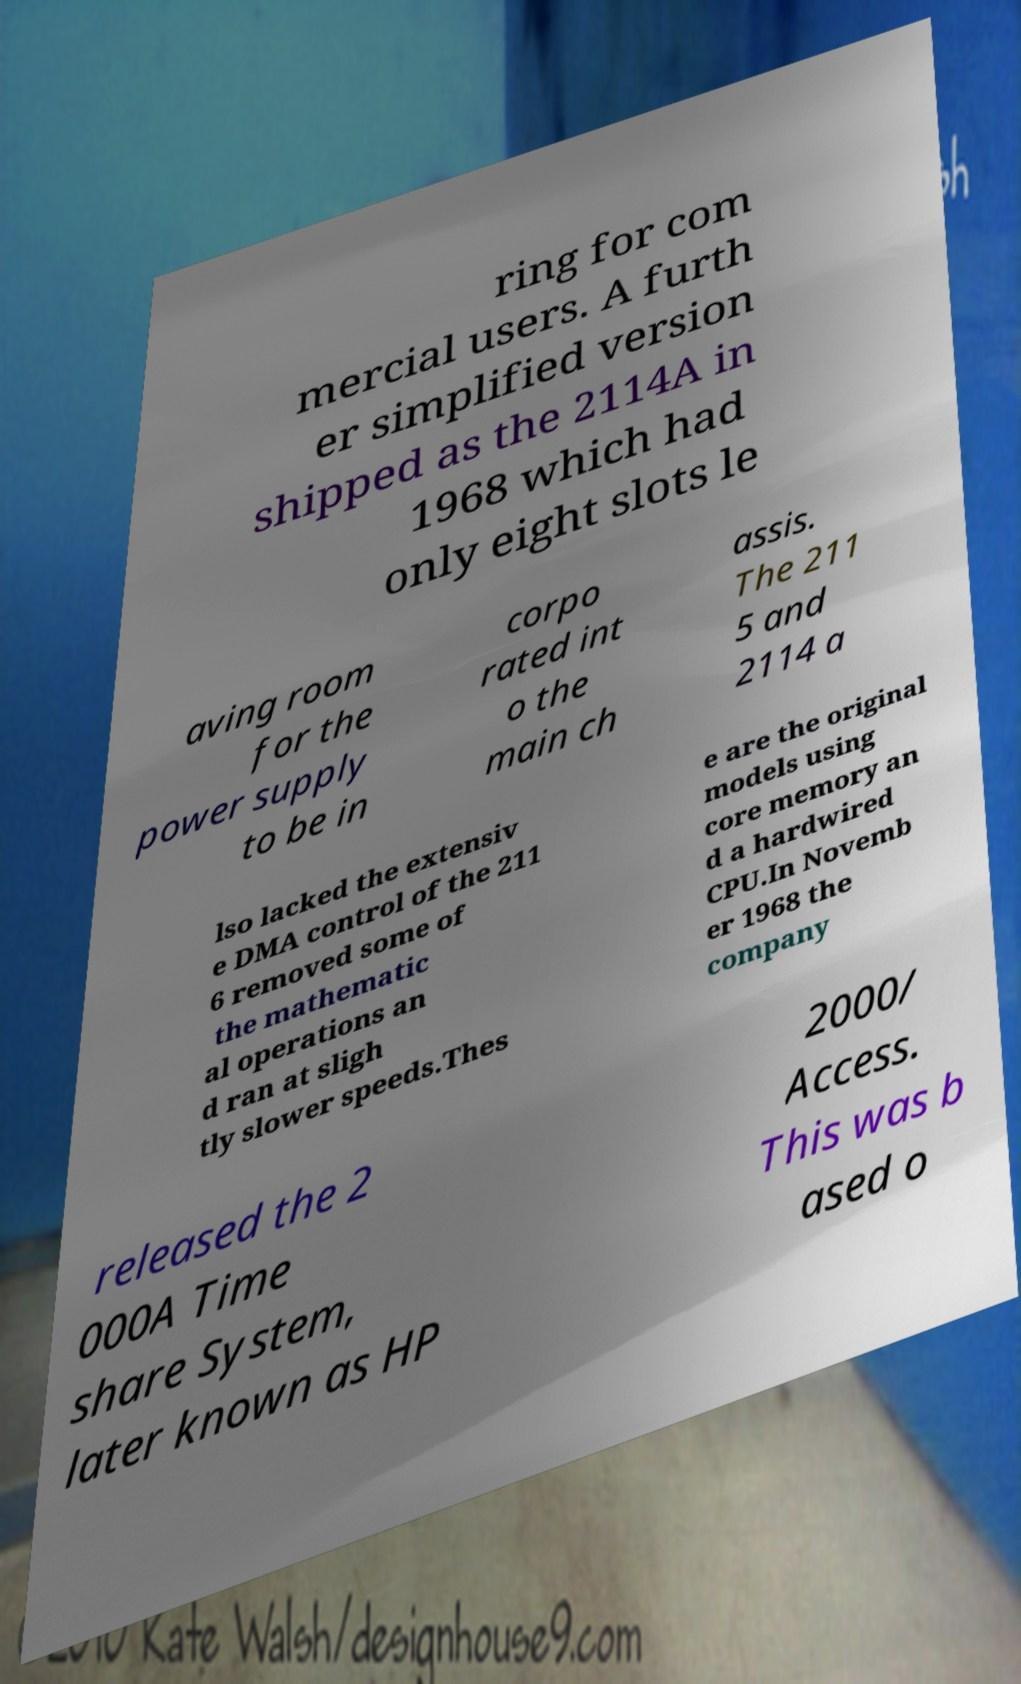There's text embedded in this image that I need extracted. Can you transcribe it verbatim? ring for com mercial users. A furth er simplified version shipped as the 2114A in 1968 which had only eight slots le aving room for the power supply to be in corpo rated int o the main ch assis. The 211 5 and 2114 a lso lacked the extensiv e DMA control of the 211 6 removed some of the mathematic al operations an d ran at sligh tly slower speeds.Thes e are the original models using core memory an d a hardwired CPU.In Novemb er 1968 the company released the 2 000A Time share System, later known as HP 2000/ Access. This was b ased o 